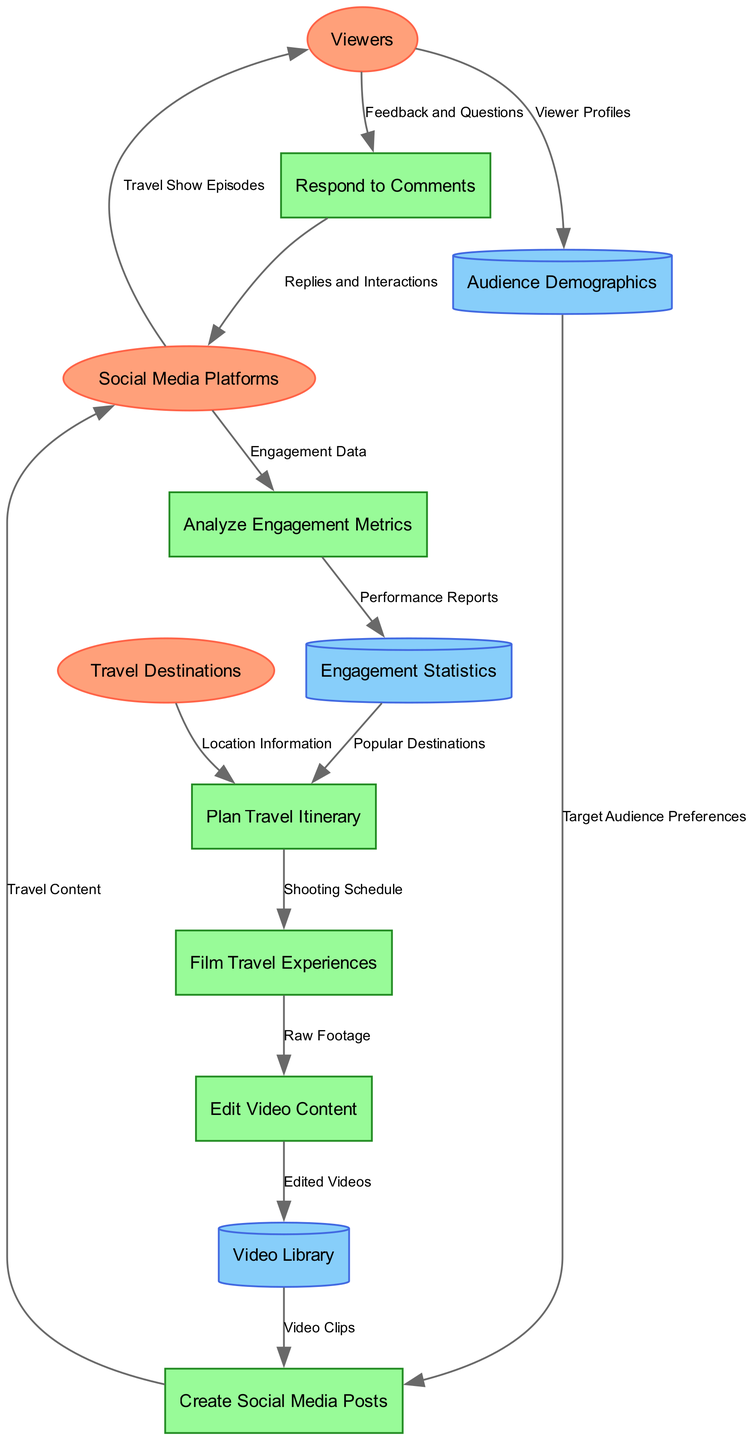What are the external entities in the diagram? The external entities include Viewers, Social Media Platforms, and Travel Destinations. These are listed at the top of the diagram as entities interacting with the processes.
Answer: Viewers, Social Media Platforms, Travel Destinations How many processes are shown in the diagram? The diagram includes a total of six processes: Plan Travel Itinerary, Film Travel Experiences, Edit Video Content, Create Social Media Posts, Respond to Comments, and Analyze Engagement Metrics.
Answer: Six What is the data flow from Viewers to Respond to Comments? The flow is labeled "Feedback and Questions," indicating that viewers engage by providing feedback and asking questions, which is essential for audience interaction.
Answer: Feedback and Questions Which data store receives "Edited Videos"? The "Video Library" is the data store that receives "Edited Videos" as a result of the editing process to store finalized content.
Answer: Video Library What feedback do viewers provide to the show? Viewers provide "Feedback and Questions" in response to the travel show episodes on social media, which is crucial for engagement and interaction.
Answer: Feedback and Questions After analyzing engagement metrics, what does the process output? The process outputs "Performance Reports," which are generated by analyzing the engagement data collected from social media platforms.
Answer: Performance Reports Which process is informed by "Popular Destinations"? The process "Plan Travel Itinerary" is informed by "Popular Destinations," indicating that previous engagement statistics influence future travel planning strategies.
Answer: Plan Travel Itinerary How do social media platforms contribute to viewer interaction? Social media platforms distribute "Travel Show Episodes" to viewers, allowing them to interact with the content and providing a basis for further engagement.
Answer: Travel Show Episodes What influences content creation in the diagram? Content creation in the "Create Social Media Posts" process is influenced by "Target Audience Preferences," which helps in tailoring content to meet viewer interests.
Answer: Target Audience Preferences 